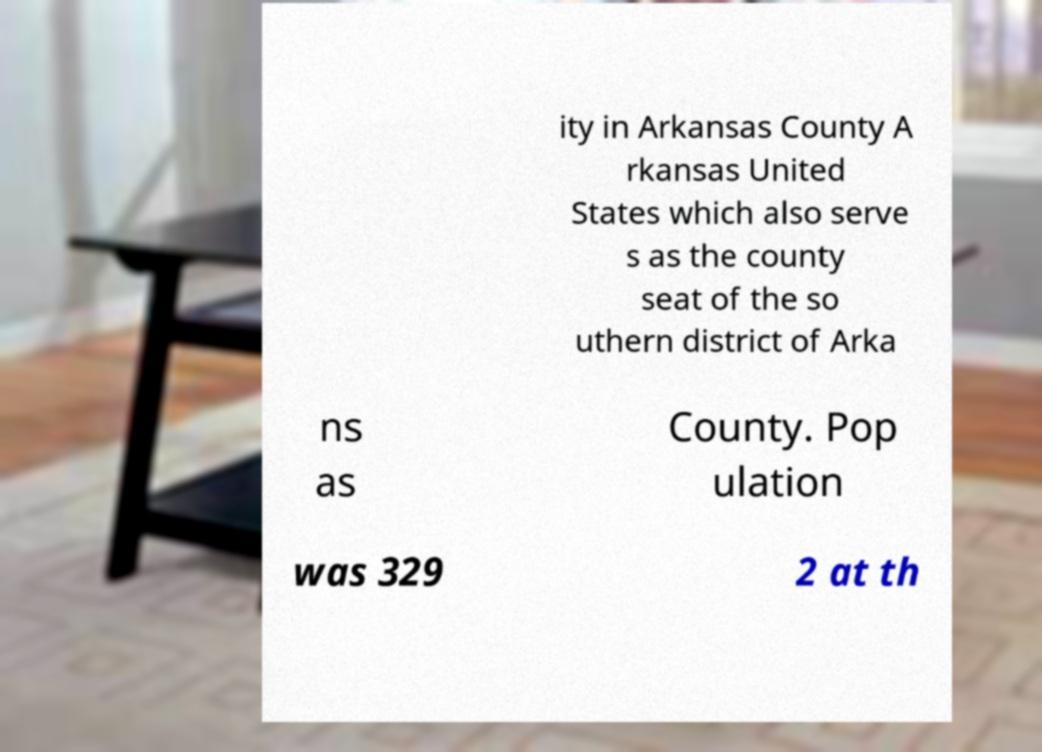Please read and relay the text visible in this image. What does it say? ity in Arkansas County A rkansas United States which also serve s as the county seat of the so uthern district of Arka ns as County. Pop ulation was 329 2 at th 